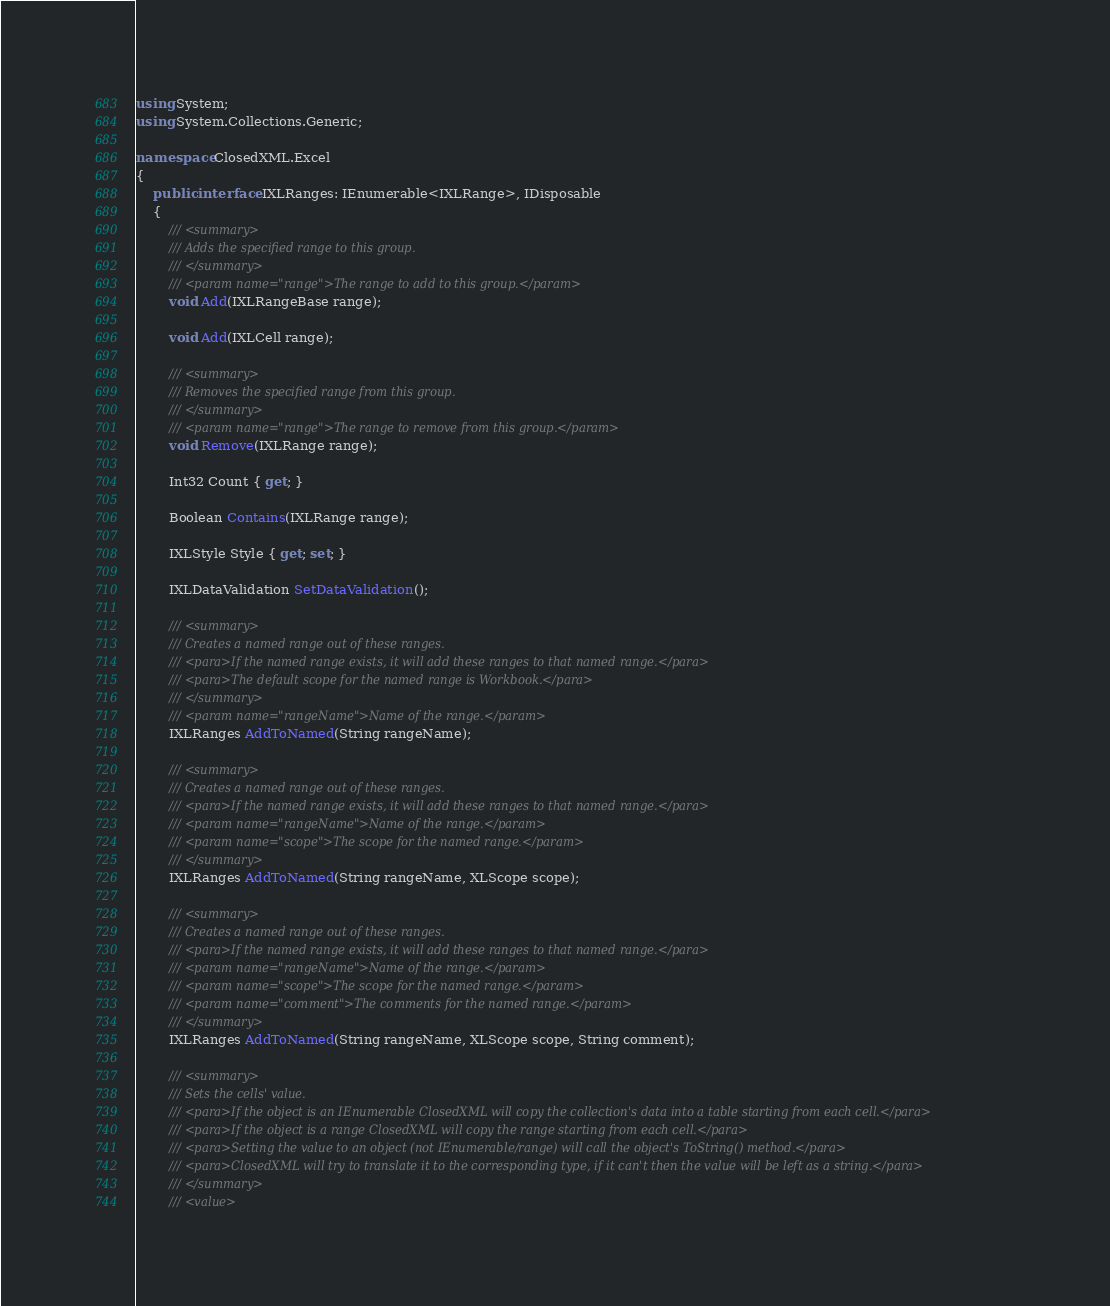<code> <loc_0><loc_0><loc_500><loc_500><_C#_>using System;
using System.Collections.Generic;

namespace ClosedXML.Excel
{
    public interface IXLRanges: IEnumerable<IXLRange>, IDisposable
    {
        /// <summary>
        /// Adds the specified range to this group.
        /// </summary>
        /// <param name="range">The range to add to this group.</param>
        void Add(IXLRangeBase range);

        void Add(IXLCell range);

        /// <summary>
        /// Removes the specified range from this group.
        /// </summary>
        /// <param name="range">The range to remove from this group.</param>
        void Remove(IXLRange range);

        Int32 Count { get; }

        Boolean Contains(IXLRange range);

        IXLStyle Style { get; set; }

        IXLDataValidation SetDataValidation();

        /// <summary>
        /// Creates a named range out of these ranges. 
        /// <para>If the named range exists, it will add these ranges to that named range.</para>
        /// <para>The default scope for the named range is Workbook.</para>
        /// </summary>
        /// <param name="rangeName">Name of the range.</param>
        IXLRanges AddToNamed(String rangeName);

        /// <summary>
        /// Creates a named range out of these ranges. 
        /// <para>If the named range exists, it will add these ranges to that named range.</para>
        /// <param name="rangeName">Name of the range.</param>
        /// <param name="scope">The scope for the named range.</param>
        /// </summary>
        IXLRanges AddToNamed(String rangeName, XLScope scope);

        /// <summary>
        /// Creates a named range out of these ranges. 
        /// <para>If the named range exists, it will add these ranges to that named range.</para>
        /// <param name="rangeName">Name of the range.</param>
        /// <param name="scope">The scope for the named range.</param>
        /// <param name="comment">The comments for the named range.</param>
        /// </summary>
        IXLRanges AddToNamed(String rangeName, XLScope scope, String comment);

        /// <summary>
        /// Sets the cells' value.
        /// <para>If the object is an IEnumerable ClosedXML will copy the collection's data into a table starting from each cell.</para>
        /// <para>If the object is a range ClosedXML will copy the range starting from each cell.</para>
        /// <para>Setting the value to an object (not IEnumerable/range) will call the object's ToString() method.</para>
        /// <para>ClosedXML will try to translate it to the corresponding type, if it can't then the value will be left as a string.</para>
        /// </summary>
        /// <value></code> 